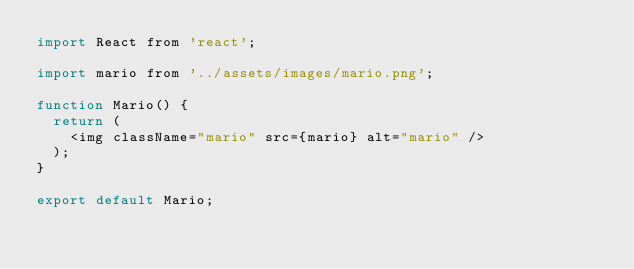<code> <loc_0><loc_0><loc_500><loc_500><_JavaScript_>import React from 'react';

import mario from '../assets/images/mario.png';

function Mario() {
  return (
    <img className="mario" src={mario} alt="mario" />
  );
}

export default Mario;</code> 